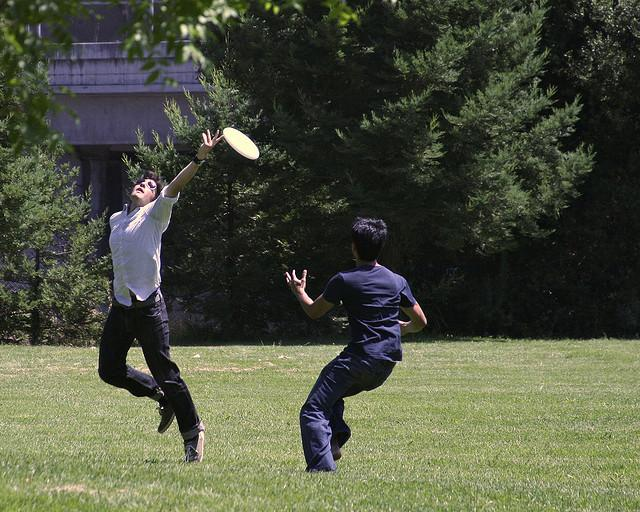The man in the white shirt is using what to touch the frisbee?

Choices:
A) thumb
B) wrist
C) fingernails
D) fingertips fingertips 